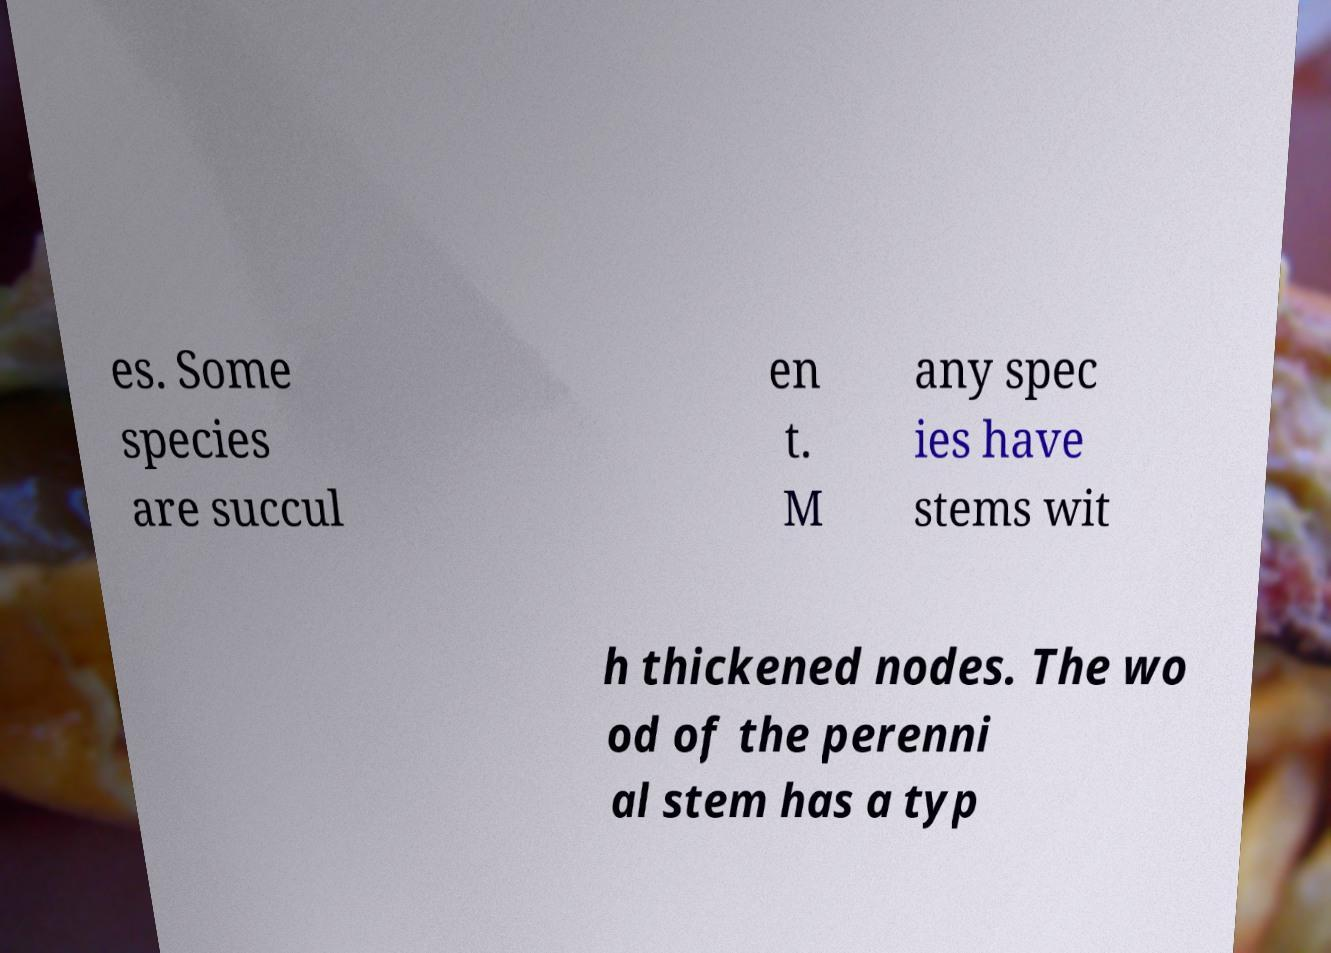What messages or text are displayed in this image? I need them in a readable, typed format. es. Some species are succul en t. M any spec ies have stems wit h thickened nodes. The wo od of the perenni al stem has a typ 